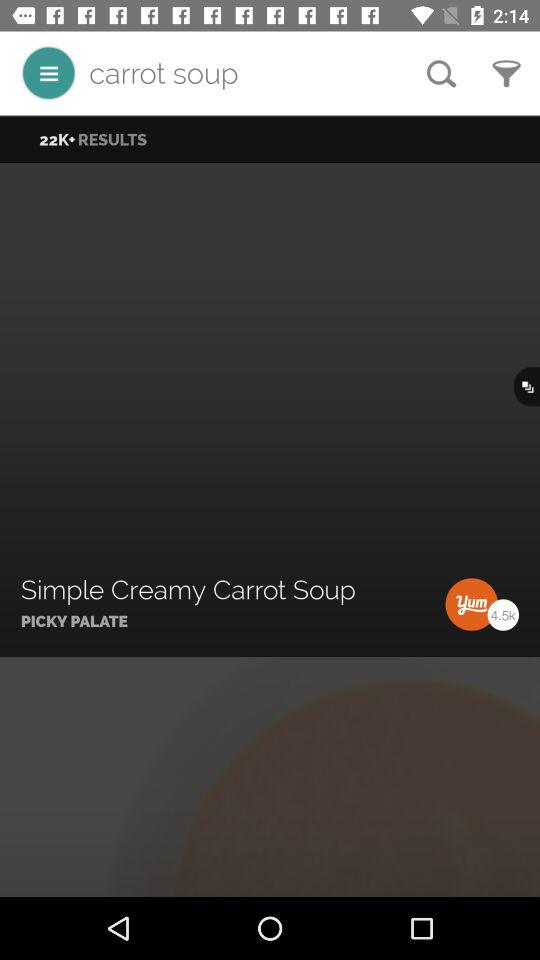For what is the person searching? The person is searching for carrot soup. 